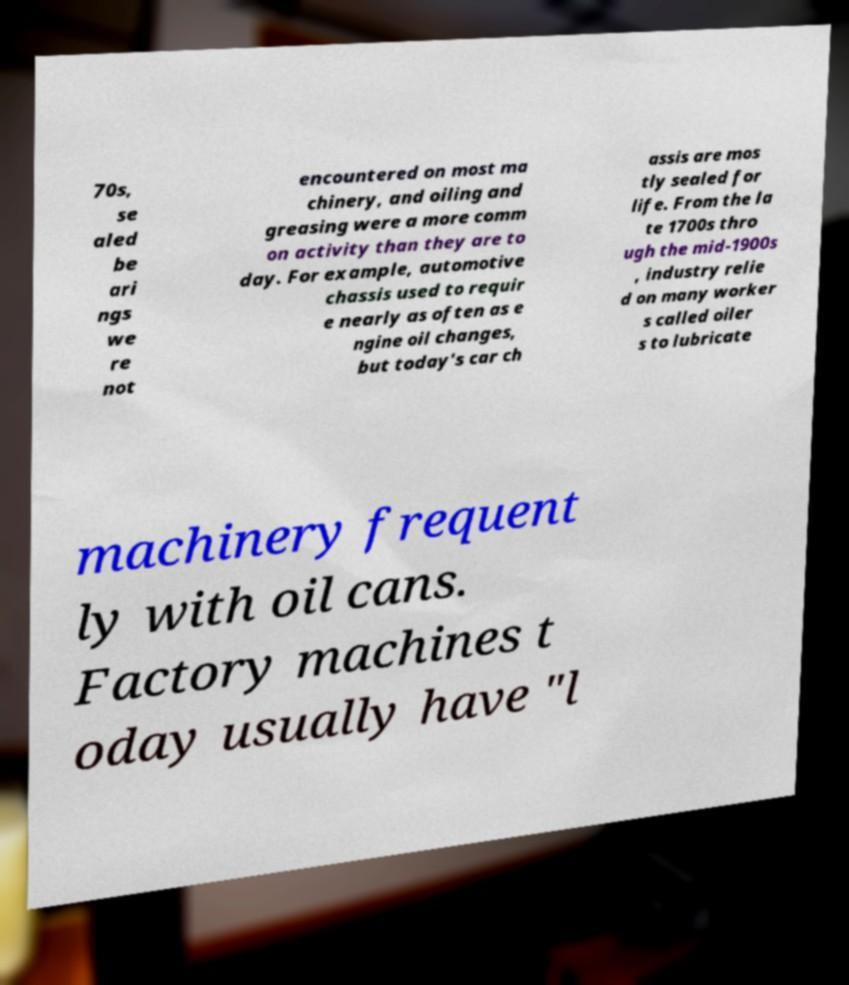Could you assist in decoding the text presented in this image and type it out clearly? 70s, se aled be ari ngs we re not encountered on most ma chinery, and oiling and greasing were a more comm on activity than they are to day. For example, automotive chassis used to requir e nearly as often as e ngine oil changes, but today's car ch assis are mos tly sealed for life. From the la te 1700s thro ugh the mid-1900s , industry relie d on many worker s called oiler s to lubricate machinery frequent ly with oil cans. Factory machines t oday usually have "l 